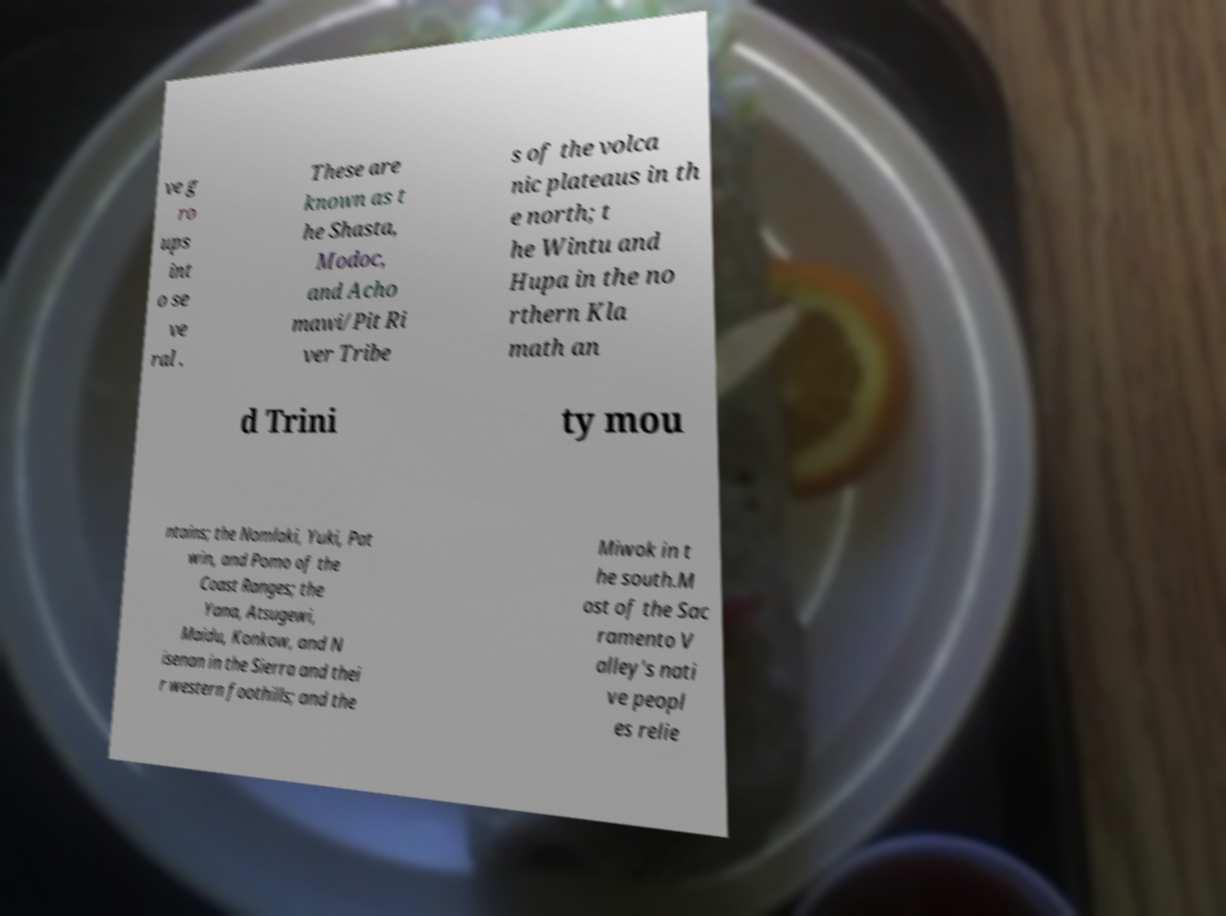Could you extract and type out the text from this image? ve g ro ups int o se ve ral . These are known as t he Shasta, Modoc, and Acho mawi/Pit Ri ver Tribe s of the volca nic plateaus in th e north; t he Wintu and Hupa in the no rthern Kla math an d Trini ty mou ntains; the Nomlaki, Yuki, Pat win, and Pomo of the Coast Ranges; the Yana, Atsugewi, Maidu, Konkow, and N isenan in the Sierra and thei r western foothills; and the Miwok in t he south.M ost of the Sac ramento V alley's nati ve peopl es relie 